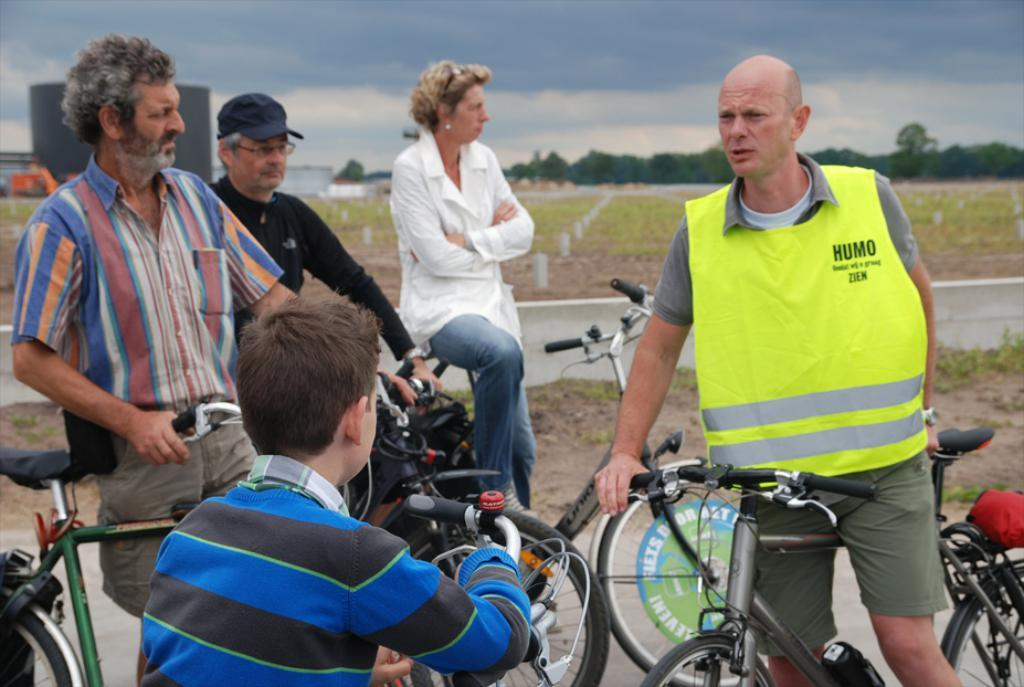What is the main subject of the image? The main subject of the image is a group of people. What are the people in the image doing? The people are holding bicycles. What is the condition of the sky in the image? The sky is cloudy in the image. What type of secretary can be seen in the image? There is no secretary present in the image; it features a group of people holding bicycles. What color is the scarf worn by the person in the image? There is no scarf visible in the image. 